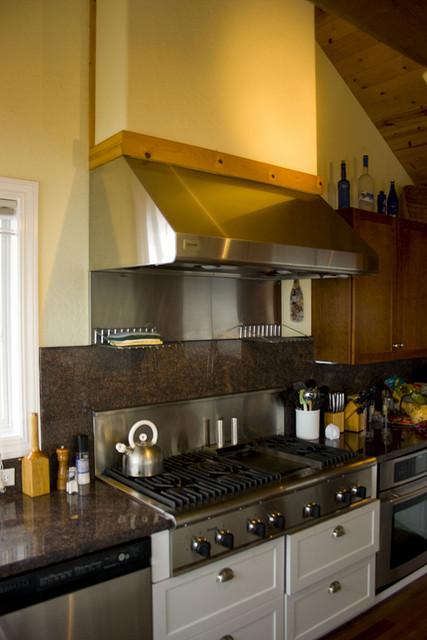What room was the picture taken of?
Short answer required. Kitchen. What is above the stove?
Be succinct. Vent. What color is the countertop?
Be succinct. Brown. What side of the stove top is the tea kettle on?
Give a very brief answer. Left. 